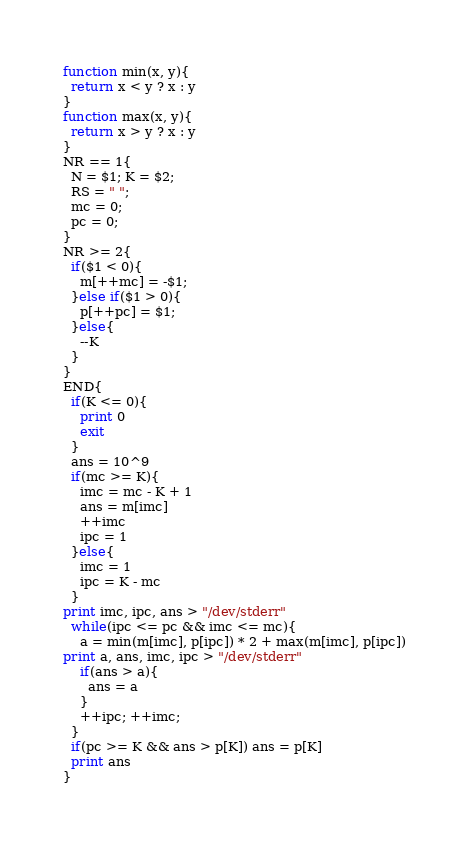Convert code to text. <code><loc_0><loc_0><loc_500><loc_500><_Awk_>function min(x, y){
  return x < y ? x : y
}
function max(x, y){
  return x > y ? x : y
}
NR == 1{
  N = $1; K = $2;
  RS = " ";
  mc = 0;
  pc = 0;
}
NR >= 2{
  if($1 < 0){
    m[++mc] = -$1;
  }else if($1 > 0){
    p[++pc] = $1;
  }else{
    --K
  }
}
END{
  if(K <= 0){
    print 0
    exit
  }
  ans = 10^9
  if(mc >= K){
    imc = mc - K + 1
    ans = m[imc]
    ++imc
    ipc = 1
  }else{
    imc = 1
    ipc = K - mc 
  }
print imc, ipc, ans > "/dev/stderr"
  while(ipc <= pc && imc <= mc){
    a = min(m[imc], p[ipc]) * 2 + max(m[imc], p[ipc])
print a, ans, imc, ipc > "/dev/stderr"
    if(ans > a){
      ans = a
    }
    ++ipc; ++imc;
  }
  if(pc >= K && ans > p[K]) ans = p[K]
  print ans
}</code> 